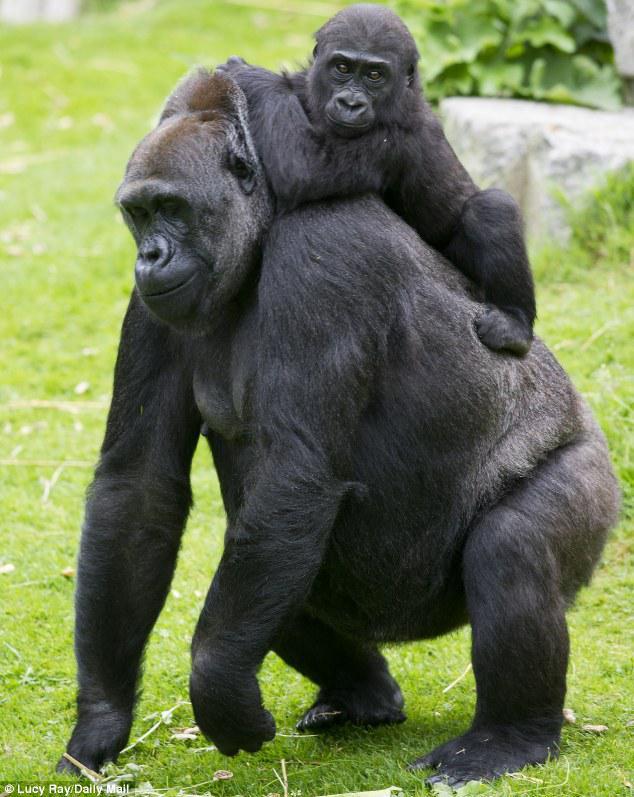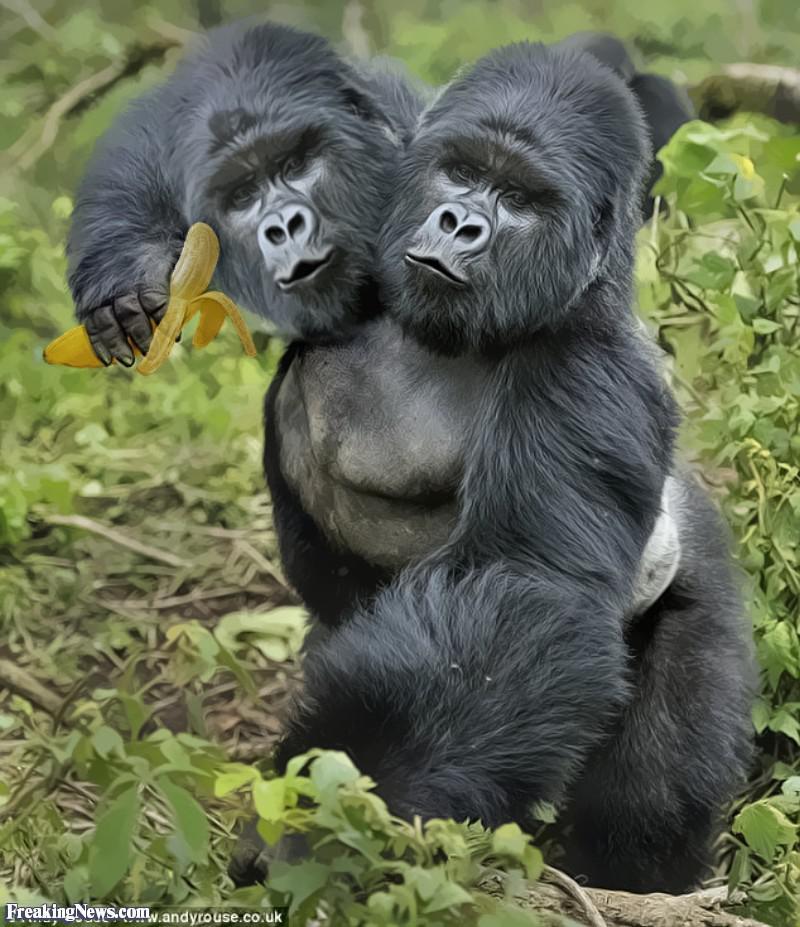The first image is the image on the left, the second image is the image on the right. Evaluate the accuracy of this statement regarding the images: "There is one small, baby gorilla being carried by its mother.". Is it true? Answer yes or no. Yes. The first image is the image on the left, the second image is the image on the right. Given the left and right images, does the statement "Left image shows a baby gorilla positioned in front of a sitting adult." hold true? Answer yes or no. No. 